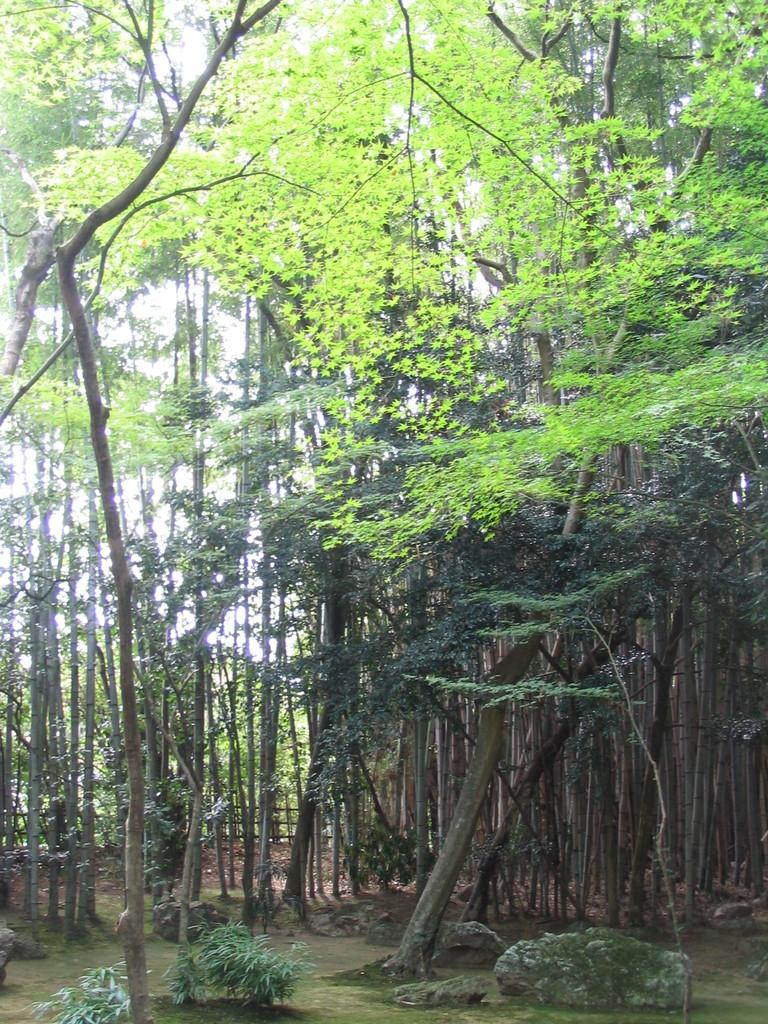What type of vegetation can be seen in the image? There are trees and plants visible in the image. What type of ground cover is present in the image? There is grass visible in the image. What part of the natural environment is visible in the image? The sky is visible in the background of the image. How many babies are visible in the image? There are no babies present in the image; it features trees, plants, grass, and the sky. What type of territory is depicted in the image? The image does not depict any specific territory; it simply shows trees, plants, grass, and the sky. 